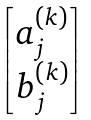<formula> <loc_0><loc_0><loc_500><loc_500>\begin{bmatrix} a _ { j } ^ { ( k ) } \\ b _ { j } ^ { ( k ) } \end{bmatrix}</formula> 